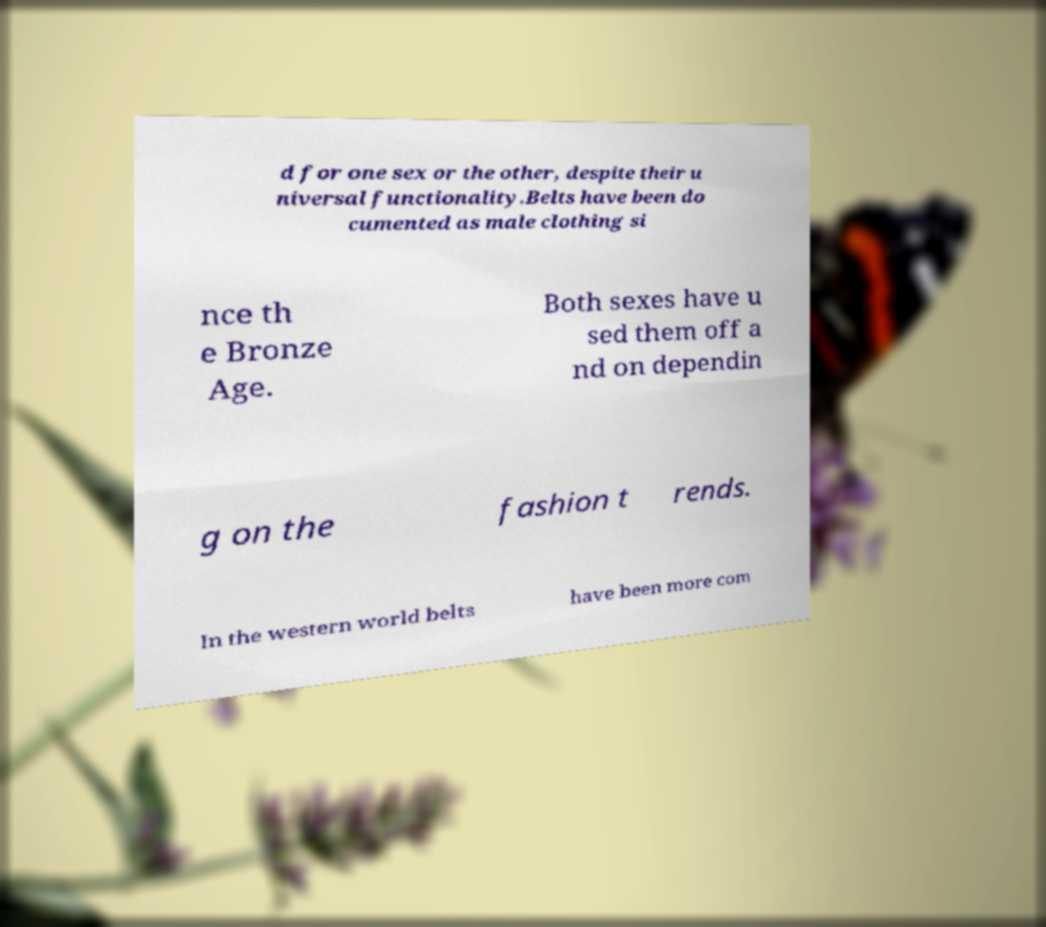Can you accurately transcribe the text from the provided image for me? d for one sex or the other, despite their u niversal functionality.Belts have been do cumented as male clothing si nce th e Bronze Age. Both sexes have u sed them off a nd on dependin g on the fashion t rends. In the western world belts have been more com 